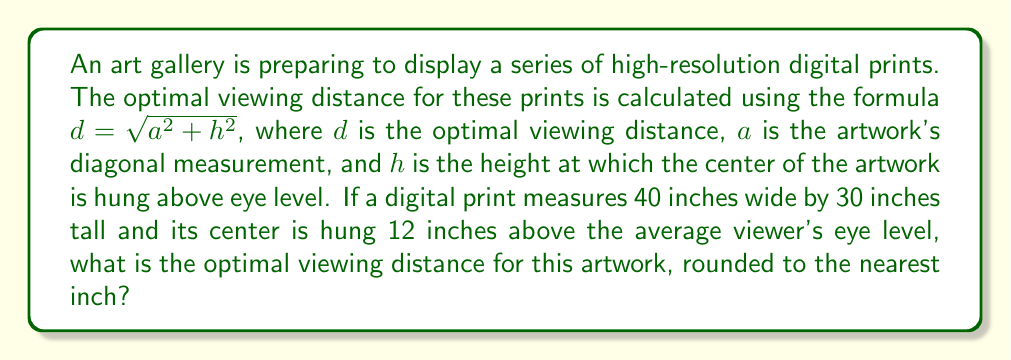Can you solve this math problem? To solve this problem, we'll follow these steps:

1) First, we need to calculate the diagonal measurement of the artwork using the Pythagorean theorem:

   $a = \sqrt{width^2 + height^2}$
   $a = \sqrt{40^2 + 30^2}$
   $a = \sqrt{1600 + 900}$
   $a = \sqrt{2500}$
   $a = 50$ inches

2) Now we have all the components for our optimal viewing distance formula:
   $a = 50$ inches (diagonal of artwork)
   $h = 12$ inches (height above eye level)

3) Let's plug these values into our formula:
   $d = \sqrt{a^2 + h^2}$
   $d = \sqrt{50^2 + 12^2}$
   $d = \sqrt{2500 + 144}$
   $d = \sqrt{2644}$

4) Calculate the square root:
   $d \approx 51.42$ inches

5) Rounding to the nearest inch:
   $d = 51$ inches
Answer: 51 inches 